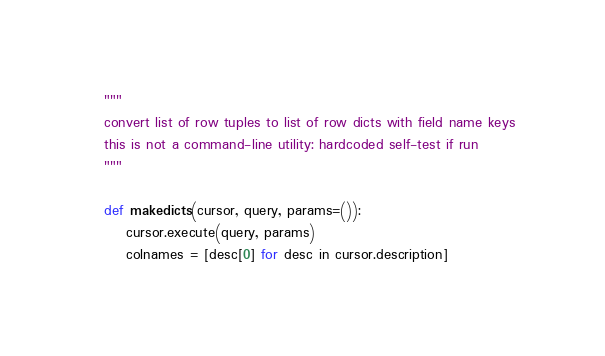<code> <loc_0><loc_0><loc_500><loc_500><_Python_>"""
convert list of row tuples to list of row dicts with field name keys
this is not a command-line utility: hardcoded self-test if run
"""

def makedicts(cursor, query, params=()):
    cursor.execute(query, params)
    colnames = [desc[0] for desc in cursor.description]</code> 